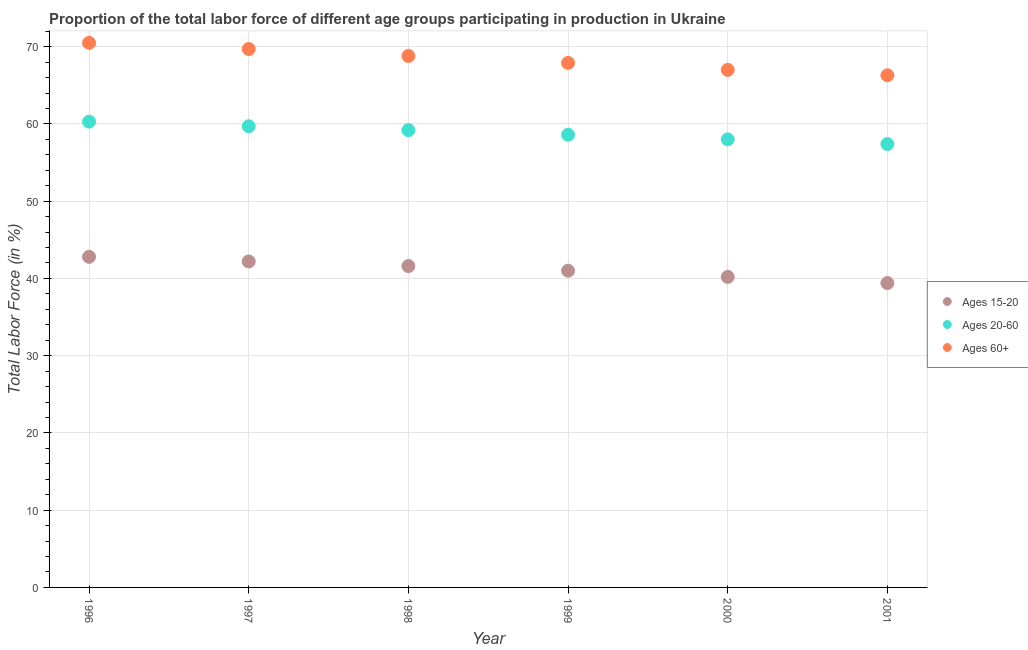Is the number of dotlines equal to the number of legend labels?
Offer a terse response. Yes. What is the percentage of labor force within the age group 20-60 in 1997?
Ensure brevity in your answer.  59.7. Across all years, what is the maximum percentage of labor force above age 60?
Your answer should be compact. 70.5. Across all years, what is the minimum percentage of labor force within the age group 20-60?
Offer a terse response. 57.4. What is the total percentage of labor force within the age group 20-60 in the graph?
Your answer should be compact. 353.2. What is the difference between the percentage of labor force within the age group 15-20 in 1997 and that in 2001?
Your response must be concise. 2.8. What is the difference between the percentage of labor force above age 60 in 2001 and the percentage of labor force within the age group 15-20 in 1998?
Offer a terse response. 24.7. What is the average percentage of labor force within the age group 15-20 per year?
Provide a short and direct response. 41.2. In the year 1996, what is the difference between the percentage of labor force within the age group 20-60 and percentage of labor force above age 60?
Your answer should be very brief. -10.2. What is the ratio of the percentage of labor force within the age group 20-60 in 1997 to that in 2001?
Give a very brief answer. 1.04. Is the percentage of labor force within the age group 20-60 in 1996 less than that in 1998?
Give a very brief answer. No. Is the difference between the percentage of labor force within the age group 15-20 in 1999 and 2000 greater than the difference between the percentage of labor force within the age group 20-60 in 1999 and 2000?
Make the answer very short. Yes. What is the difference between the highest and the second highest percentage of labor force within the age group 15-20?
Offer a very short reply. 0.6. What is the difference between the highest and the lowest percentage of labor force within the age group 20-60?
Provide a succinct answer. 2.9. In how many years, is the percentage of labor force within the age group 20-60 greater than the average percentage of labor force within the age group 20-60 taken over all years?
Offer a very short reply. 3. Is the sum of the percentage of labor force within the age group 20-60 in 1997 and 1999 greater than the maximum percentage of labor force within the age group 15-20 across all years?
Give a very brief answer. Yes. How many years are there in the graph?
Provide a succinct answer. 6. What is the difference between two consecutive major ticks on the Y-axis?
Your answer should be compact. 10. Are the values on the major ticks of Y-axis written in scientific E-notation?
Provide a succinct answer. No. Does the graph contain grids?
Offer a very short reply. Yes. How many legend labels are there?
Your answer should be compact. 3. How are the legend labels stacked?
Offer a very short reply. Vertical. What is the title of the graph?
Keep it short and to the point. Proportion of the total labor force of different age groups participating in production in Ukraine. Does "Manufactures" appear as one of the legend labels in the graph?
Your answer should be compact. No. What is the Total Labor Force (in %) of Ages 15-20 in 1996?
Provide a succinct answer. 42.8. What is the Total Labor Force (in %) of Ages 20-60 in 1996?
Offer a terse response. 60.3. What is the Total Labor Force (in %) in Ages 60+ in 1996?
Provide a succinct answer. 70.5. What is the Total Labor Force (in %) of Ages 15-20 in 1997?
Give a very brief answer. 42.2. What is the Total Labor Force (in %) of Ages 20-60 in 1997?
Offer a very short reply. 59.7. What is the Total Labor Force (in %) of Ages 60+ in 1997?
Your response must be concise. 69.7. What is the Total Labor Force (in %) of Ages 15-20 in 1998?
Your answer should be compact. 41.6. What is the Total Labor Force (in %) of Ages 20-60 in 1998?
Provide a succinct answer. 59.2. What is the Total Labor Force (in %) in Ages 60+ in 1998?
Ensure brevity in your answer.  68.8. What is the Total Labor Force (in %) of Ages 15-20 in 1999?
Offer a very short reply. 41. What is the Total Labor Force (in %) of Ages 20-60 in 1999?
Your answer should be compact. 58.6. What is the Total Labor Force (in %) of Ages 60+ in 1999?
Offer a very short reply. 67.9. What is the Total Labor Force (in %) in Ages 15-20 in 2000?
Your answer should be compact. 40.2. What is the Total Labor Force (in %) of Ages 15-20 in 2001?
Give a very brief answer. 39.4. What is the Total Labor Force (in %) of Ages 20-60 in 2001?
Offer a terse response. 57.4. What is the Total Labor Force (in %) in Ages 60+ in 2001?
Give a very brief answer. 66.3. Across all years, what is the maximum Total Labor Force (in %) in Ages 15-20?
Offer a terse response. 42.8. Across all years, what is the maximum Total Labor Force (in %) in Ages 20-60?
Ensure brevity in your answer.  60.3. Across all years, what is the maximum Total Labor Force (in %) of Ages 60+?
Provide a short and direct response. 70.5. Across all years, what is the minimum Total Labor Force (in %) of Ages 15-20?
Provide a short and direct response. 39.4. Across all years, what is the minimum Total Labor Force (in %) of Ages 20-60?
Your answer should be compact. 57.4. Across all years, what is the minimum Total Labor Force (in %) of Ages 60+?
Give a very brief answer. 66.3. What is the total Total Labor Force (in %) of Ages 15-20 in the graph?
Provide a succinct answer. 247.2. What is the total Total Labor Force (in %) of Ages 20-60 in the graph?
Offer a terse response. 353.2. What is the total Total Labor Force (in %) in Ages 60+ in the graph?
Provide a succinct answer. 410.2. What is the difference between the Total Labor Force (in %) in Ages 15-20 in 1996 and that in 1997?
Keep it short and to the point. 0.6. What is the difference between the Total Labor Force (in %) of Ages 20-60 in 1996 and that in 1997?
Your response must be concise. 0.6. What is the difference between the Total Labor Force (in %) of Ages 60+ in 1996 and that in 1997?
Your answer should be compact. 0.8. What is the difference between the Total Labor Force (in %) in Ages 20-60 in 1996 and that in 2000?
Make the answer very short. 2.3. What is the difference between the Total Labor Force (in %) in Ages 15-20 in 1996 and that in 2001?
Offer a terse response. 3.4. What is the difference between the Total Labor Force (in %) in Ages 60+ in 1996 and that in 2001?
Your response must be concise. 4.2. What is the difference between the Total Labor Force (in %) of Ages 20-60 in 1997 and that in 1998?
Your answer should be compact. 0.5. What is the difference between the Total Labor Force (in %) of Ages 15-20 in 1997 and that in 1999?
Offer a terse response. 1.2. What is the difference between the Total Labor Force (in %) of Ages 20-60 in 1997 and that in 1999?
Ensure brevity in your answer.  1.1. What is the difference between the Total Labor Force (in %) of Ages 60+ in 1997 and that in 1999?
Keep it short and to the point. 1.8. What is the difference between the Total Labor Force (in %) of Ages 15-20 in 1997 and that in 2000?
Make the answer very short. 2. What is the difference between the Total Labor Force (in %) of Ages 20-60 in 1997 and that in 2000?
Provide a short and direct response. 1.7. What is the difference between the Total Labor Force (in %) of Ages 15-20 in 1997 and that in 2001?
Make the answer very short. 2.8. What is the difference between the Total Labor Force (in %) in Ages 20-60 in 1997 and that in 2001?
Offer a terse response. 2.3. What is the difference between the Total Labor Force (in %) of Ages 20-60 in 1998 and that in 1999?
Your response must be concise. 0.6. What is the difference between the Total Labor Force (in %) of Ages 60+ in 1998 and that in 1999?
Keep it short and to the point. 0.9. What is the difference between the Total Labor Force (in %) of Ages 20-60 in 1998 and that in 2000?
Ensure brevity in your answer.  1.2. What is the difference between the Total Labor Force (in %) of Ages 60+ in 1998 and that in 2000?
Ensure brevity in your answer.  1.8. What is the difference between the Total Labor Force (in %) in Ages 20-60 in 1998 and that in 2001?
Your answer should be very brief. 1.8. What is the difference between the Total Labor Force (in %) in Ages 60+ in 1998 and that in 2001?
Offer a terse response. 2.5. What is the difference between the Total Labor Force (in %) in Ages 20-60 in 1999 and that in 2000?
Provide a short and direct response. 0.6. What is the difference between the Total Labor Force (in %) of Ages 60+ in 1999 and that in 2000?
Provide a succinct answer. 0.9. What is the difference between the Total Labor Force (in %) in Ages 20-60 in 1999 and that in 2001?
Your answer should be very brief. 1.2. What is the difference between the Total Labor Force (in %) in Ages 60+ in 1999 and that in 2001?
Your answer should be very brief. 1.6. What is the difference between the Total Labor Force (in %) of Ages 15-20 in 2000 and that in 2001?
Your answer should be compact. 0.8. What is the difference between the Total Labor Force (in %) in Ages 20-60 in 2000 and that in 2001?
Provide a short and direct response. 0.6. What is the difference between the Total Labor Force (in %) of Ages 15-20 in 1996 and the Total Labor Force (in %) of Ages 20-60 in 1997?
Your response must be concise. -16.9. What is the difference between the Total Labor Force (in %) in Ages 15-20 in 1996 and the Total Labor Force (in %) in Ages 60+ in 1997?
Give a very brief answer. -26.9. What is the difference between the Total Labor Force (in %) of Ages 15-20 in 1996 and the Total Labor Force (in %) of Ages 20-60 in 1998?
Ensure brevity in your answer.  -16.4. What is the difference between the Total Labor Force (in %) of Ages 20-60 in 1996 and the Total Labor Force (in %) of Ages 60+ in 1998?
Give a very brief answer. -8.5. What is the difference between the Total Labor Force (in %) in Ages 15-20 in 1996 and the Total Labor Force (in %) in Ages 20-60 in 1999?
Offer a terse response. -15.8. What is the difference between the Total Labor Force (in %) of Ages 15-20 in 1996 and the Total Labor Force (in %) of Ages 60+ in 1999?
Offer a terse response. -25.1. What is the difference between the Total Labor Force (in %) in Ages 15-20 in 1996 and the Total Labor Force (in %) in Ages 20-60 in 2000?
Make the answer very short. -15.2. What is the difference between the Total Labor Force (in %) in Ages 15-20 in 1996 and the Total Labor Force (in %) in Ages 60+ in 2000?
Keep it short and to the point. -24.2. What is the difference between the Total Labor Force (in %) of Ages 20-60 in 1996 and the Total Labor Force (in %) of Ages 60+ in 2000?
Provide a succinct answer. -6.7. What is the difference between the Total Labor Force (in %) in Ages 15-20 in 1996 and the Total Labor Force (in %) in Ages 20-60 in 2001?
Provide a succinct answer. -14.6. What is the difference between the Total Labor Force (in %) in Ages 15-20 in 1996 and the Total Labor Force (in %) in Ages 60+ in 2001?
Give a very brief answer. -23.5. What is the difference between the Total Labor Force (in %) of Ages 20-60 in 1996 and the Total Labor Force (in %) of Ages 60+ in 2001?
Keep it short and to the point. -6. What is the difference between the Total Labor Force (in %) in Ages 15-20 in 1997 and the Total Labor Force (in %) in Ages 20-60 in 1998?
Offer a terse response. -17. What is the difference between the Total Labor Force (in %) in Ages 15-20 in 1997 and the Total Labor Force (in %) in Ages 60+ in 1998?
Provide a short and direct response. -26.6. What is the difference between the Total Labor Force (in %) in Ages 20-60 in 1997 and the Total Labor Force (in %) in Ages 60+ in 1998?
Ensure brevity in your answer.  -9.1. What is the difference between the Total Labor Force (in %) of Ages 15-20 in 1997 and the Total Labor Force (in %) of Ages 20-60 in 1999?
Your answer should be very brief. -16.4. What is the difference between the Total Labor Force (in %) of Ages 15-20 in 1997 and the Total Labor Force (in %) of Ages 60+ in 1999?
Keep it short and to the point. -25.7. What is the difference between the Total Labor Force (in %) in Ages 20-60 in 1997 and the Total Labor Force (in %) in Ages 60+ in 1999?
Your answer should be compact. -8.2. What is the difference between the Total Labor Force (in %) in Ages 15-20 in 1997 and the Total Labor Force (in %) in Ages 20-60 in 2000?
Provide a succinct answer. -15.8. What is the difference between the Total Labor Force (in %) in Ages 15-20 in 1997 and the Total Labor Force (in %) in Ages 60+ in 2000?
Offer a terse response. -24.8. What is the difference between the Total Labor Force (in %) in Ages 20-60 in 1997 and the Total Labor Force (in %) in Ages 60+ in 2000?
Keep it short and to the point. -7.3. What is the difference between the Total Labor Force (in %) in Ages 15-20 in 1997 and the Total Labor Force (in %) in Ages 20-60 in 2001?
Your answer should be very brief. -15.2. What is the difference between the Total Labor Force (in %) in Ages 15-20 in 1997 and the Total Labor Force (in %) in Ages 60+ in 2001?
Your answer should be compact. -24.1. What is the difference between the Total Labor Force (in %) of Ages 15-20 in 1998 and the Total Labor Force (in %) of Ages 60+ in 1999?
Offer a very short reply. -26.3. What is the difference between the Total Labor Force (in %) in Ages 20-60 in 1998 and the Total Labor Force (in %) in Ages 60+ in 1999?
Your answer should be very brief. -8.7. What is the difference between the Total Labor Force (in %) in Ages 15-20 in 1998 and the Total Labor Force (in %) in Ages 20-60 in 2000?
Provide a succinct answer. -16.4. What is the difference between the Total Labor Force (in %) in Ages 15-20 in 1998 and the Total Labor Force (in %) in Ages 60+ in 2000?
Your response must be concise. -25.4. What is the difference between the Total Labor Force (in %) in Ages 15-20 in 1998 and the Total Labor Force (in %) in Ages 20-60 in 2001?
Your answer should be compact. -15.8. What is the difference between the Total Labor Force (in %) of Ages 15-20 in 1998 and the Total Labor Force (in %) of Ages 60+ in 2001?
Offer a very short reply. -24.7. What is the difference between the Total Labor Force (in %) of Ages 15-20 in 1999 and the Total Labor Force (in %) of Ages 60+ in 2000?
Provide a short and direct response. -26. What is the difference between the Total Labor Force (in %) in Ages 15-20 in 1999 and the Total Labor Force (in %) in Ages 20-60 in 2001?
Ensure brevity in your answer.  -16.4. What is the difference between the Total Labor Force (in %) in Ages 15-20 in 1999 and the Total Labor Force (in %) in Ages 60+ in 2001?
Offer a terse response. -25.3. What is the difference between the Total Labor Force (in %) in Ages 15-20 in 2000 and the Total Labor Force (in %) in Ages 20-60 in 2001?
Make the answer very short. -17.2. What is the difference between the Total Labor Force (in %) in Ages 15-20 in 2000 and the Total Labor Force (in %) in Ages 60+ in 2001?
Provide a short and direct response. -26.1. What is the difference between the Total Labor Force (in %) of Ages 20-60 in 2000 and the Total Labor Force (in %) of Ages 60+ in 2001?
Your answer should be compact. -8.3. What is the average Total Labor Force (in %) in Ages 15-20 per year?
Provide a short and direct response. 41.2. What is the average Total Labor Force (in %) in Ages 20-60 per year?
Your answer should be very brief. 58.87. What is the average Total Labor Force (in %) in Ages 60+ per year?
Your answer should be compact. 68.37. In the year 1996, what is the difference between the Total Labor Force (in %) of Ages 15-20 and Total Labor Force (in %) of Ages 20-60?
Offer a very short reply. -17.5. In the year 1996, what is the difference between the Total Labor Force (in %) in Ages 15-20 and Total Labor Force (in %) in Ages 60+?
Give a very brief answer. -27.7. In the year 1996, what is the difference between the Total Labor Force (in %) in Ages 20-60 and Total Labor Force (in %) in Ages 60+?
Give a very brief answer. -10.2. In the year 1997, what is the difference between the Total Labor Force (in %) in Ages 15-20 and Total Labor Force (in %) in Ages 20-60?
Your response must be concise. -17.5. In the year 1997, what is the difference between the Total Labor Force (in %) in Ages 15-20 and Total Labor Force (in %) in Ages 60+?
Offer a very short reply. -27.5. In the year 1997, what is the difference between the Total Labor Force (in %) of Ages 20-60 and Total Labor Force (in %) of Ages 60+?
Provide a succinct answer. -10. In the year 1998, what is the difference between the Total Labor Force (in %) in Ages 15-20 and Total Labor Force (in %) in Ages 20-60?
Your answer should be compact. -17.6. In the year 1998, what is the difference between the Total Labor Force (in %) of Ages 15-20 and Total Labor Force (in %) of Ages 60+?
Make the answer very short. -27.2. In the year 1999, what is the difference between the Total Labor Force (in %) of Ages 15-20 and Total Labor Force (in %) of Ages 20-60?
Ensure brevity in your answer.  -17.6. In the year 1999, what is the difference between the Total Labor Force (in %) in Ages 15-20 and Total Labor Force (in %) in Ages 60+?
Ensure brevity in your answer.  -26.9. In the year 2000, what is the difference between the Total Labor Force (in %) in Ages 15-20 and Total Labor Force (in %) in Ages 20-60?
Your response must be concise. -17.8. In the year 2000, what is the difference between the Total Labor Force (in %) of Ages 15-20 and Total Labor Force (in %) of Ages 60+?
Your answer should be compact. -26.8. In the year 2000, what is the difference between the Total Labor Force (in %) of Ages 20-60 and Total Labor Force (in %) of Ages 60+?
Provide a succinct answer. -9. In the year 2001, what is the difference between the Total Labor Force (in %) in Ages 15-20 and Total Labor Force (in %) in Ages 20-60?
Provide a succinct answer. -18. In the year 2001, what is the difference between the Total Labor Force (in %) in Ages 15-20 and Total Labor Force (in %) in Ages 60+?
Give a very brief answer. -26.9. What is the ratio of the Total Labor Force (in %) in Ages 15-20 in 1996 to that in 1997?
Offer a terse response. 1.01. What is the ratio of the Total Labor Force (in %) of Ages 20-60 in 1996 to that in 1997?
Provide a succinct answer. 1.01. What is the ratio of the Total Labor Force (in %) in Ages 60+ in 1996 to that in 1997?
Provide a short and direct response. 1.01. What is the ratio of the Total Labor Force (in %) of Ages 15-20 in 1996 to that in 1998?
Provide a succinct answer. 1.03. What is the ratio of the Total Labor Force (in %) in Ages 20-60 in 1996 to that in 1998?
Offer a terse response. 1.02. What is the ratio of the Total Labor Force (in %) of Ages 60+ in 1996 to that in 1998?
Provide a succinct answer. 1.02. What is the ratio of the Total Labor Force (in %) of Ages 15-20 in 1996 to that in 1999?
Ensure brevity in your answer.  1.04. What is the ratio of the Total Labor Force (in %) in Ages 60+ in 1996 to that in 1999?
Keep it short and to the point. 1.04. What is the ratio of the Total Labor Force (in %) in Ages 15-20 in 1996 to that in 2000?
Your answer should be compact. 1.06. What is the ratio of the Total Labor Force (in %) in Ages 20-60 in 1996 to that in 2000?
Offer a terse response. 1.04. What is the ratio of the Total Labor Force (in %) of Ages 60+ in 1996 to that in 2000?
Offer a terse response. 1.05. What is the ratio of the Total Labor Force (in %) of Ages 15-20 in 1996 to that in 2001?
Offer a very short reply. 1.09. What is the ratio of the Total Labor Force (in %) of Ages 20-60 in 1996 to that in 2001?
Keep it short and to the point. 1.05. What is the ratio of the Total Labor Force (in %) of Ages 60+ in 1996 to that in 2001?
Ensure brevity in your answer.  1.06. What is the ratio of the Total Labor Force (in %) in Ages 15-20 in 1997 to that in 1998?
Give a very brief answer. 1.01. What is the ratio of the Total Labor Force (in %) in Ages 20-60 in 1997 to that in 1998?
Make the answer very short. 1.01. What is the ratio of the Total Labor Force (in %) in Ages 60+ in 1997 to that in 1998?
Your answer should be compact. 1.01. What is the ratio of the Total Labor Force (in %) of Ages 15-20 in 1997 to that in 1999?
Your response must be concise. 1.03. What is the ratio of the Total Labor Force (in %) in Ages 20-60 in 1997 to that in 1999?
Make the answer very short. 1.02. What is the ratio of the Total Labor Force (in %) in Ages 60+ in 1997 to that in 1999?
Offer a terse response. 1.03. What is the ratio of the Total Labor Force (in %) of Ages 15-20 in 1997 to that in 2000?
Make the answer very short. 1.05. What is the ratio of the Total Labor Force (in %) of Ages 20-60 in 1997 to that in 2000?
Offer a terse response. 1.03. What is the ratio of the Total Labor Force (in %) of Ages 60+ in 1997 to that in 2000?
Your answer should be compact. 1.04. What is the ratio of the Total Labor Force (in %) of Ages 15-20 in 1997 to that in 2001?
Provide a succinct answer. 1.07. What is the ratio of the Total Labor Force (in %) of Ages 20-60 in 1997 to that in 2001?
Provide a short and direct response. 1.04. What is the ratio of the Total Labor Force (in %) in Ages 60+ in 1997 to that in 2001?
Keep it short and to the point. 1.05. What is the ratio of the Total Labor Force (in %) in Ages 15-20 in 1998 to that in 1999?
Your answer should be very brief. 1.01. What is the ratio of the Total Labor Force (in %) in Ages 20-60 in 1998 to that in 1999?
Offer a terse response. 1.01. What is the ratio of the Total Labor Force (in %) of Ages 60+ in 1998 to that in 1999?
Make the answer very short. 1.01. What is the ratio of the Total Labor Force (in %) of Ages 15-20 in 1998 to that in 2000?
Keep it short and to the point. 1.03. What is the ratio of the Total Labor Force (in %) in Ages 20-60 in 1998 to that in 2000?
Offer a terse response. 1.02. What is the ratio of the Total Labor Force (in %) of Ages 60+ in 1998 to that in 2000?
Provide a short and direct response. 1.03. What is the ratio of the Total Labor Force (in %) of Ages 15-20 in 1998 to that in 2001?
Offer a very short reply. 1.06. What is the ratio of the Total Labor Force (in %) in Ages 20-60 in 1998 to that in 2001?
Offer a terse response. 1.03. What is the ratio of the Total Labor Force (in %) of Ages 60+ in 1998 to that in 2001?
Ensure brevity in your answer.  1.04. What is the ratio of the Total Labor Force (in %) of Ages 15-20 in 1999 to that in 2000?
Your answer should be very brief. 1.02. What is the ratio of the Total Labor Force (in %) in Ages 20-60 in 1999 to that in 2000?
Your answer should be very brief. 1.01. What is the ratio of the Total Labor Force (in %) in Ages 60+ in 1999 to that in 2000?
Offer a very short reply. 1.01. What is the ratio of the Total Labor Force (in %) of Ages 15-20 in 1999 to that in 2001?
Give a very brief answer. 1.04. What is the ratio of the Total Labor Force (in %) in Ages 20-60 in 1999 to that in 2001?
Provide a short and direct response. 1.02. What is the ratio of the Total Labor Force (in %) in Ages 60+ in 1999 to that in 2001?
Offer a very short reply. 1.02. What is the ratio of the Total Labor Force (in %) in Ages 15-20 in 2000 to that in 2001?
Give a very brief answer. 1.02. What is the ratio of the Total Labor Force (in %) of Ages 20-60 in 2000 to that in 2001?
Provide a short and direct response. 1.01. What is the ratio of the Total Labor Force (in %) of Ages 60+ in 2000 to that in 2001?
Keep it short and to the point. 1.01. What is the difference between the highest and the lowest Total Labor Force (in %) of Ages 15-20?
Ensure brevity in your answer.  3.4. What is the difference between the highest and the lowest Total Labor Force (in %) of Ages 60+?
Make the answer very short. 4.2. 